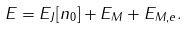Convert formula to latex. <formula><loc_0><loc_0><loc_500><loc_500>E = E _ { J } [ n _ { 0 } ] + E _ { M } + E _ { M , e } .</formula> 